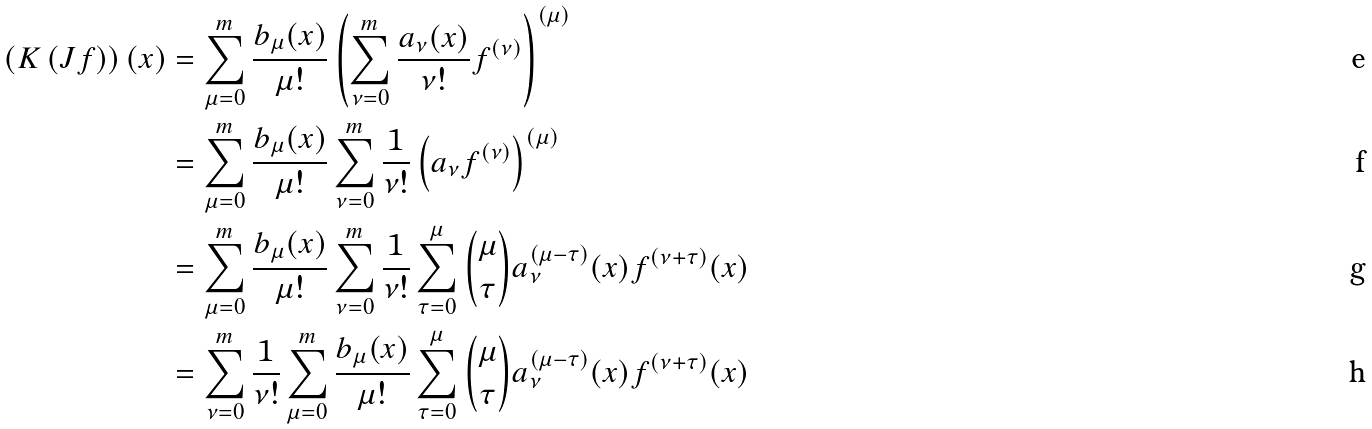<formula> <loc_0><loc_0><loc_500><loc_500>\left ( K \left ( J f \right ) \right ) ( x ) & = \sum _ { \mu = 0 } ^ { m } \frac { b _ { \mu } ( x ) } { \mu ! } \left ( \sum _ { \nu = 0 } ^ { m } \frac { a _ { \nu } ( x ) } { \nu ! } f ^ { ( \nu ) } \right ) ^ { ( \mu ) } \\ & = \sum _ { \mu = 0 } ^ { m } \frac { b _ { \mu } ( x ) } { \mu ! } \sum _ { \nu = 0 } ^ { m } \frac { 1 } { \nu ! } \left ( a _ { \nu } f ^ { ( \nu ) } \right ) ^ { ( \mu ) } \\ & = \sum _ { \mu = 0 } ^ { m } \frac { b _ { \mu } ( x ) } { \mu ! } \sum _ { \nu = 0 } ^ { m } \frac { 1 } { \nu ! } \sum _ { \tau = 0 } ^ { \mu } \binom { \mu } { \tau } a _ { \nu } ^ { ( \mu - \tau ) } ( x ) f ^ { ( \nu + \tau ) } ( x ) \\ & = \sum _ { \nu = 0 } ^ { m } \frac { 1 } { \nu ! } \sum _ { \mu = 0 } ^ { m } \frac { b _ { \mu } ( x ) } { \mu ! } \sum _ { \tau = 0 } ^ { \mu } \binom { \mu } { \tau } a _ { \nu } ^ { ( \mu - \tau ) } ( x ) f ^ { ( \nu + \tau ) } ( x )</formula> 